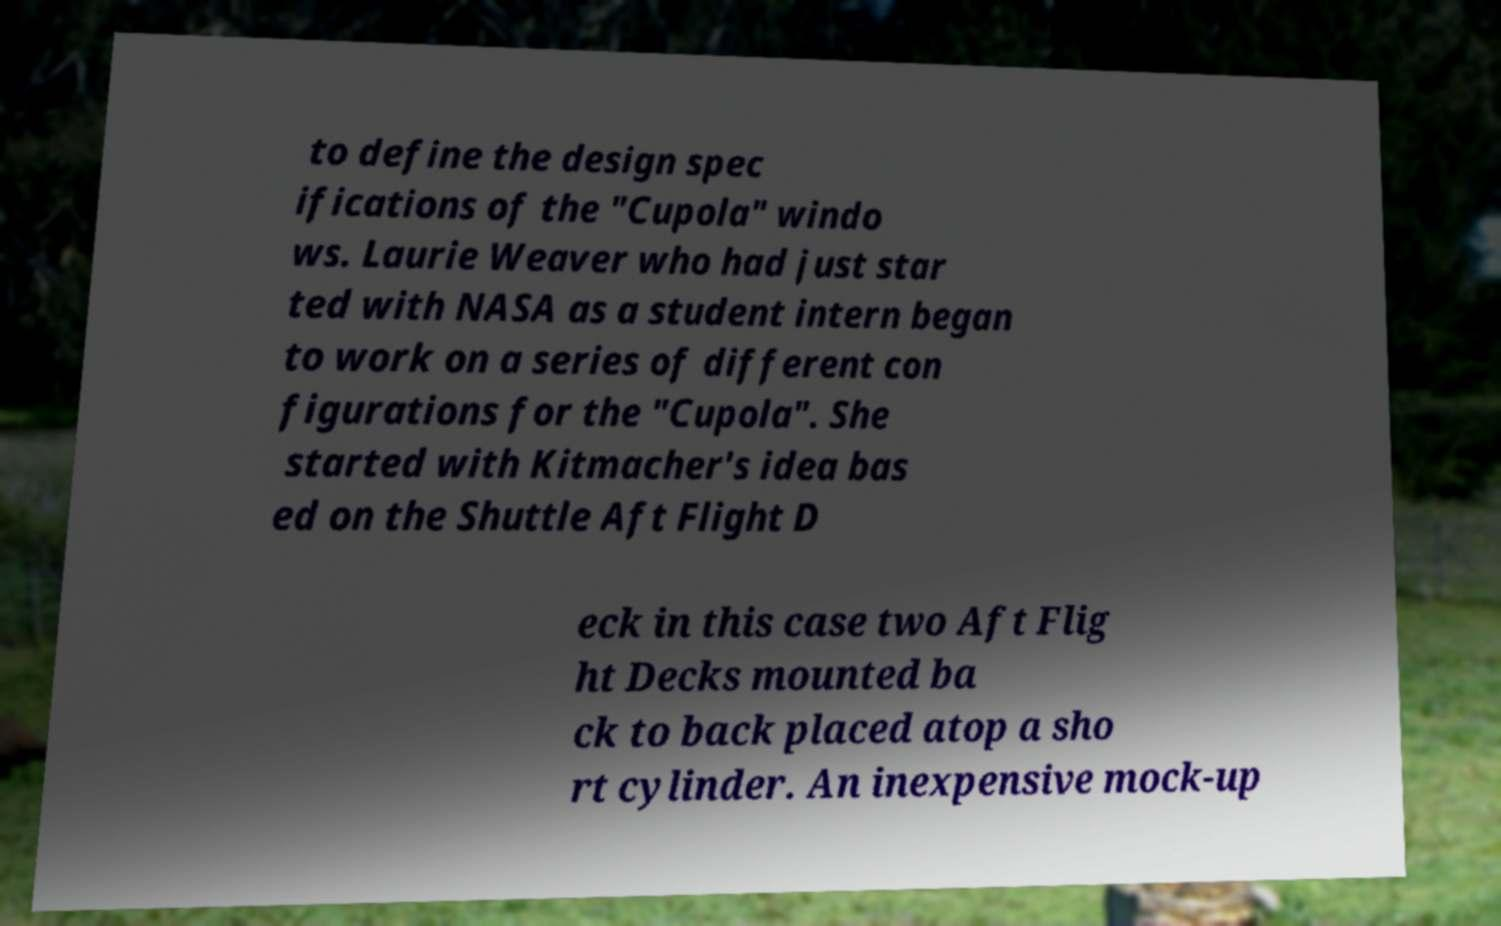Can you accurately transcribe the text from the provided image for me? to define the design spec ifications of the "Cupola" windo ws. Laurie Weaver who had just star ted with NASA as a student intern began to work on a series of different con figurations for the "Cupola". She started with Kitmacher's idea bas ed on the Shuttle Aft Flight D eck in this case two Aft Flig ht Decks mounted ba ck to back placed atop a sho rt cylinder. An inexpensive mock-up 